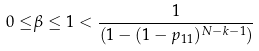Convert formula to latex. <formula><loc_0><loc_0><loc_500><loc_500>0 \leq & \beta \leq 1 < \frac { 1 } { ( 1 - ( 1 - p _ { 1 1 } ) ^ { N - k - 1 } ) }</formula> 